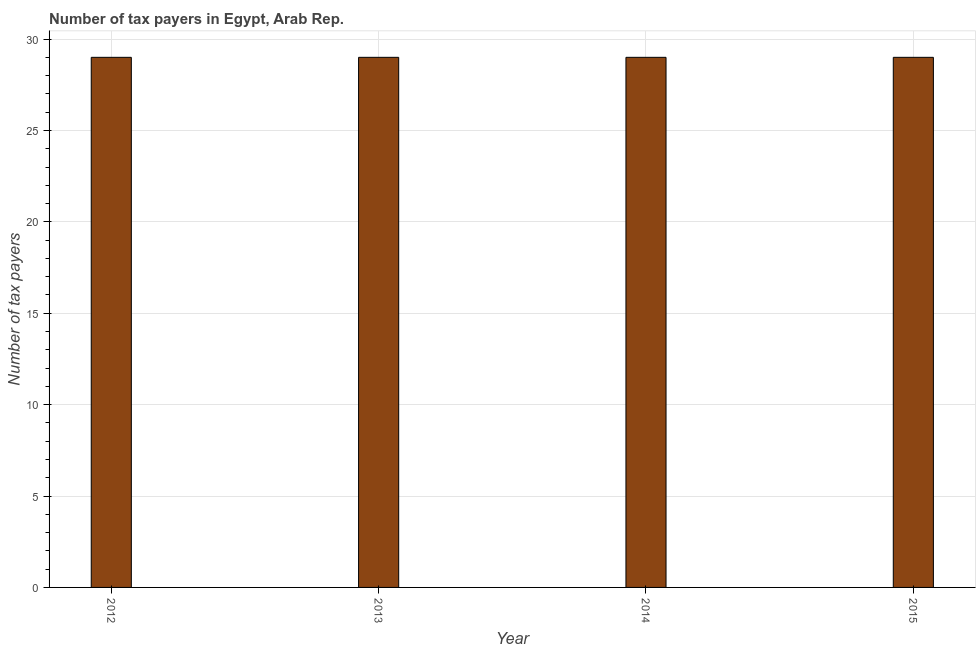What is the title of the graph?
Provide a succinct answer. Number of tax payers in Egypt, Arab Rep. What is the label or title of the Y-axis?
Your answer should be very brief. Number of tax payers. In which year was the number of tax payers maximum?
Make the answer very short. 2012. In which year was the number of tax payers minimum?
Ensure brevity in your answer.  2012. What is the sum of the number of tax payers?
Make the answer very short. 116. What is the difference between the number of tax payers in 2012 and 2014?
Ensure brevity in your answer.  0. In how many years, is the number of tax payers greater than 7 ?
Offer a terse response. 4. Do a majority of the years between 2015 and 2014 (inclusive) have number of tax payers greater than 8 ?
Provide a short and direct response. No. Is the number of tax payers in 2012 less than that in 2014?
Keep it short and to the point. No. What is the difference between the highest and the second highest number of tax payers?
Provide a succinct answer. 0. Is the sum of the number of tax payers in 2013 and 2015 greater than the maximum number of tax payers across all years?
Offer a very short reply. Yes. In how many years, is the number of tax payers greater than the average number of tax payers taken over all years?
Ensure brevity in your answer.  0. How many bars are there?
Your answer should be very brief. 4. What is the difference between two consecutive major ticks on the Y-axis?
Your answer should be compact. 5. What is the Number of tax payers in 2014?
Provide a succinct answer. 29. What is the Number of tax payers in 2015?
Your response must be concise. 29. What is the difference between the Number of tax payers in 2012 and 2013?
Ensure brevity in your answer.  0. What is the difference between the Number of tax payers in 2013 and 2015?
Offer a terse response. 0. What is the ratio of the Number of tax payers in 2012 to that in 2013?
Offer a terse response. 1. What is the ratio of the Number of tax payers in 2012 to that in 2014?
Offer a terse response. 1. What is the ratio of the Number of tax payers in 2013 to that in 2014?
Your answer should be very brief. 1. What is the ratio of the Number of tax payers in 2014 to that in 2015?
Give a very brief answer. 1. 